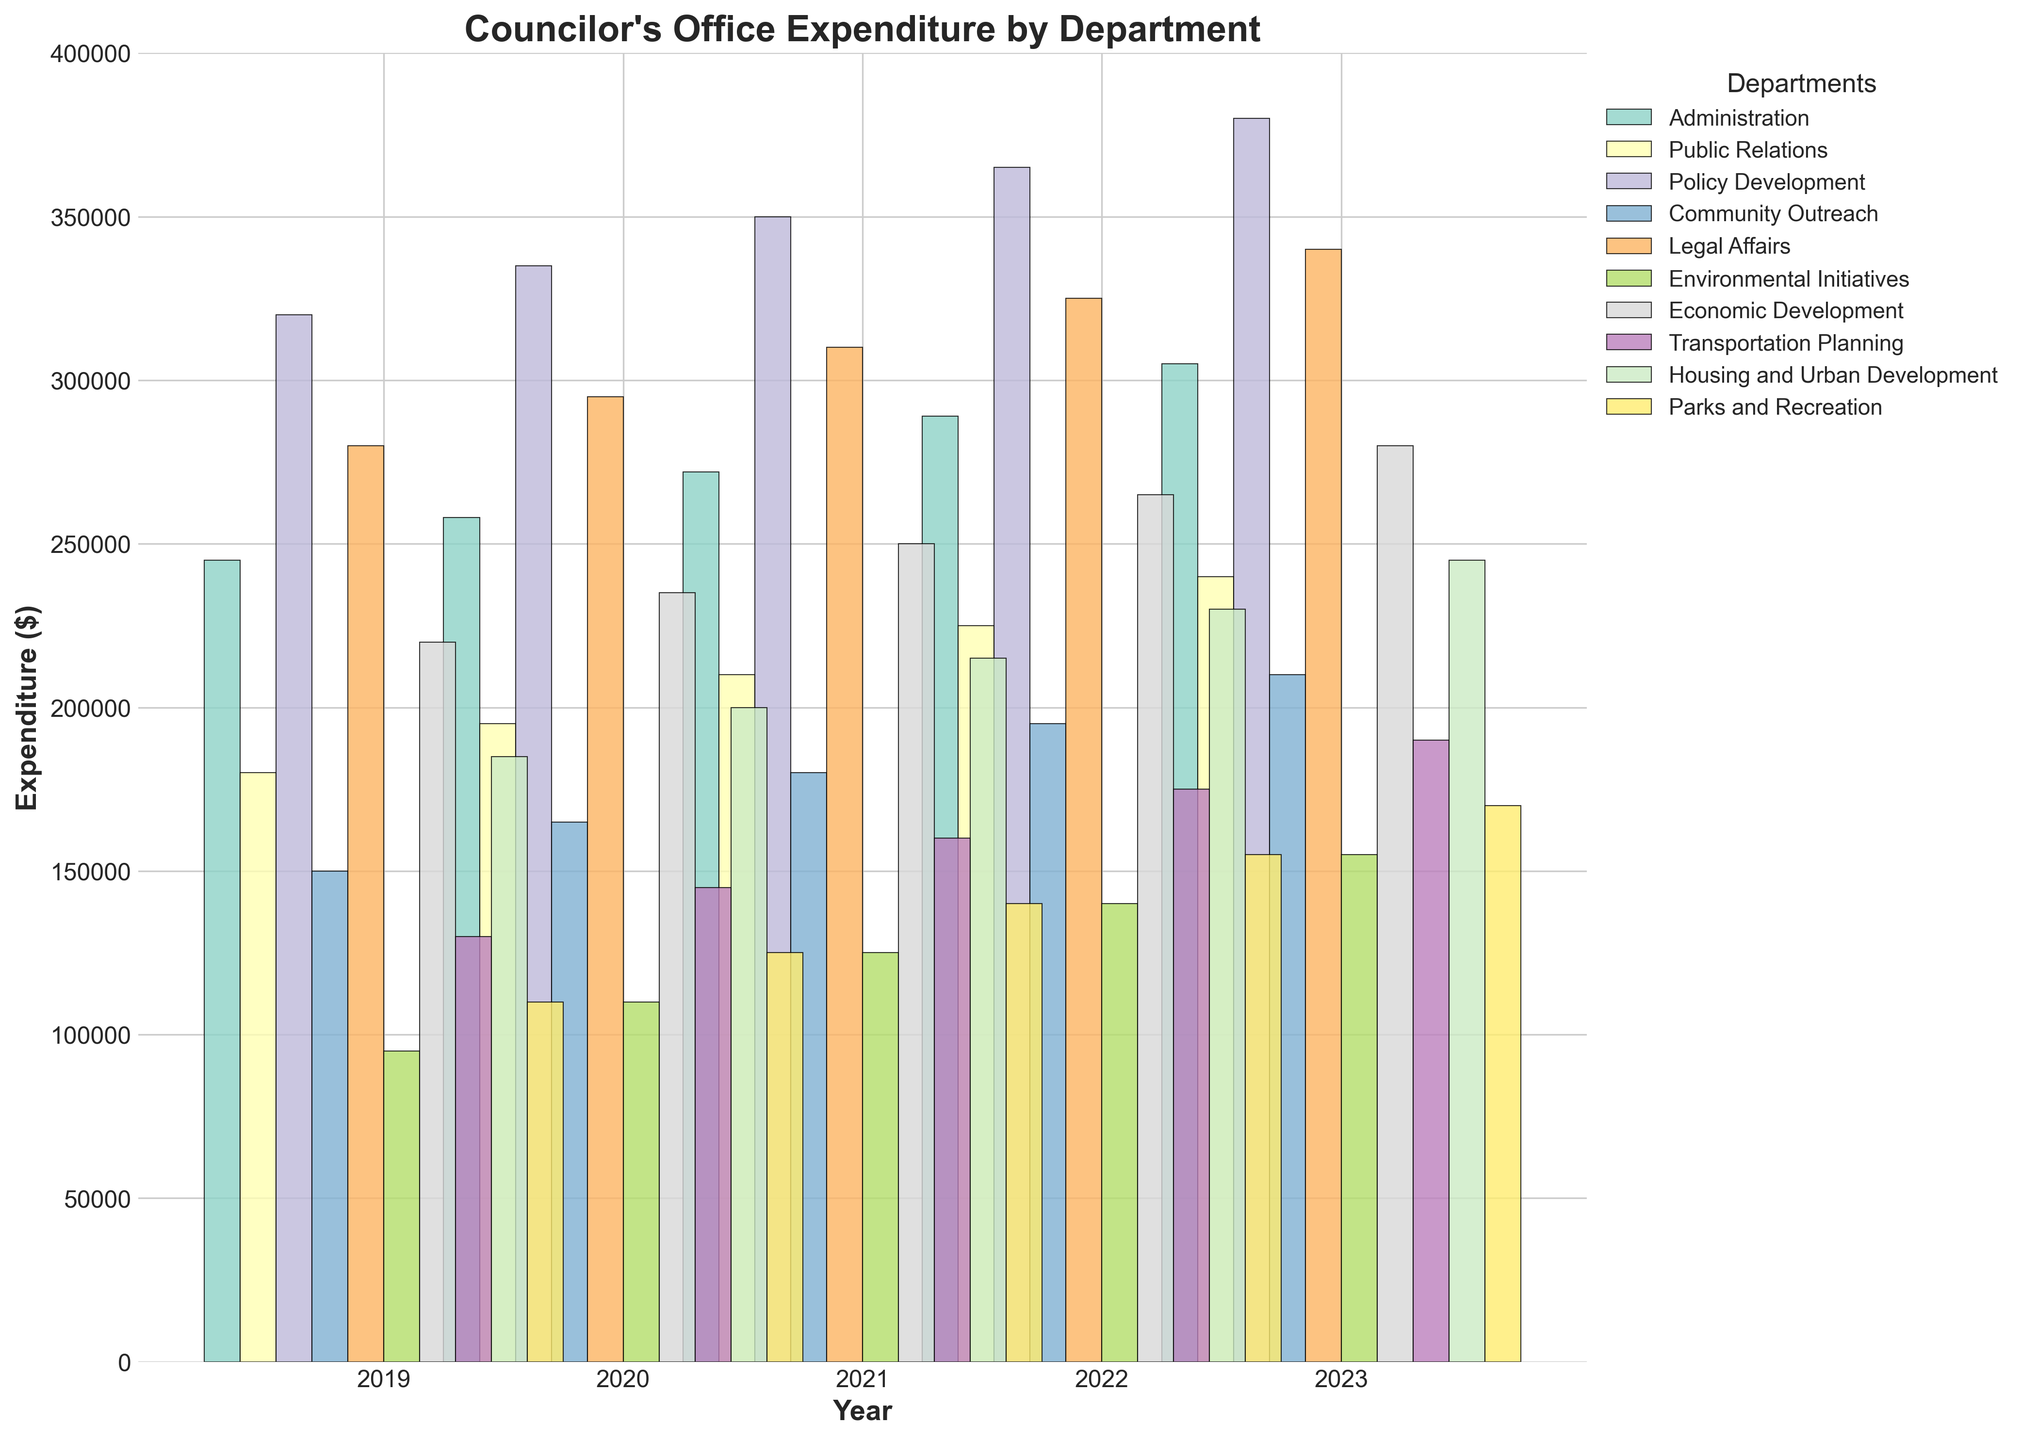How has the expenditure on Public Relations changed from 2019 to 2023? In 2019, the expenditure on Public Relations was $180,000. In 2023, it was $240,000. The change can be calculated as $240,000 - $180,000 = $60,000.
Answer: Increased by $60,000 Which department had the highest expenditure in 2023? By comparing the bar heights for 2023, Policy Development had the tallest bar, indicating the highest expenditure.
Answer: Policy Development What was the total expenditure on Administration and Legal Affairs in 2022? The expenditure on Administration in 2022 was $289,000 and on Legal Affairs was $325,000. The total is $289,000 + $325,000 = $614,000.
Answer: $614,000 Which department saw the most significant increase in expenditure from 2019 to 2023? By comparing the changes for each department, Environmental Initiatives increased from $95,000 in 2019 to $155,000 in 2023, which is an increase of $60,000. Other departments' increases are less significant.
Answer: Environmental Initiatives How did expenditure on Parks and Recreation in 2021 compare to Transportation Planning in the same year? Expenditure on Parks and Recreation in 2021 was $140,000, while on Transportation Planning it was $160,000. Thus, Transportation Planning had a higher expenditure.
Answer: Transportation Planning had higher expenditure What was the average expenditure on Community Outreach over the 5 years? Summing the expenditures: $150,000 + $165,000 + $180,000 + $195,000 + $210,000 = $900,000. Dividing by 5: $900,000 / 5 = $180,000.
Answer: $180,000 Which year had the lowest total expenditure across all departments? Summing each year's expenditures: 2019 (1,875,000), 2020 (2,058,000), 2021 (2,212,000), 2022 (2,359,000), 2023 (2,475,000), 2019 has the lowest.
Answer: 2019 Was the expenditure on Economic Development consistently increasing each year? The expenditure on Economic Development increased every year from $220,000 in 2019 to $280,000 in 2023 without any decrease.
Answer: Yes Which two departments had expenditures closer to each other in 2020? In 2020, Parks and Recreation had an expense of $125,000, and Environmental Initiatives had $110,000, making them closer in value compared to other departments.
Answer: Parks and Recreation and Environmental Initiatives What is the difference in expenditure between Administration and Housing and Urban Development in 2021? Administration had $272,000, and Housing and Urban Development had $215,000 in 2021. The difference is $272,000 - $215,000 = $57,000.
Answer: $57,000 